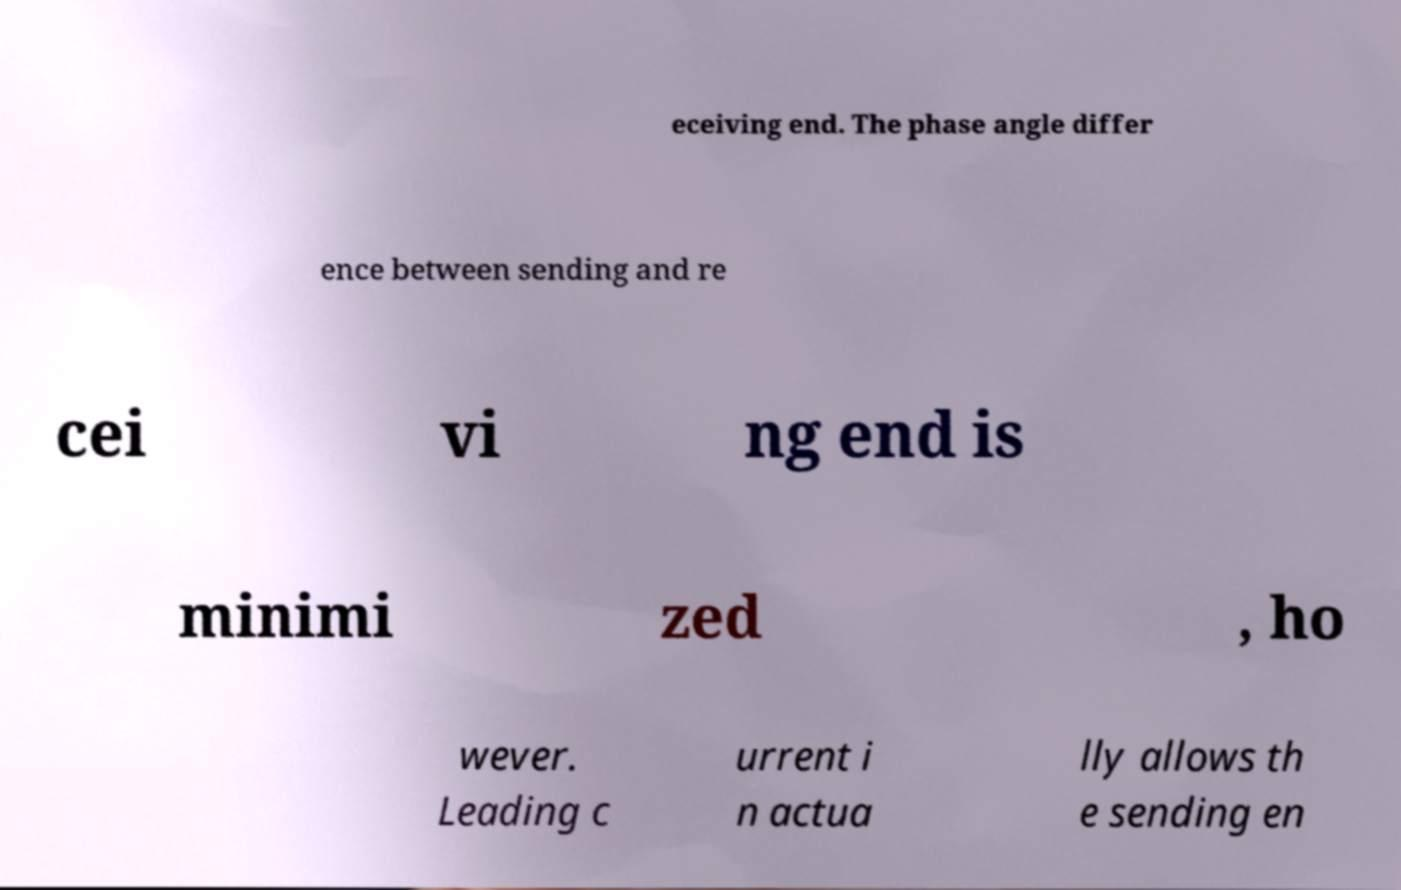Could you assist in decoding the text presented in this image and type it out clearly? eceiving end. The phase angle differ ence between sending and re cei vi ng end is minimi zed , ho wever. Leading c urrent i n actua lly allows th e sending en 